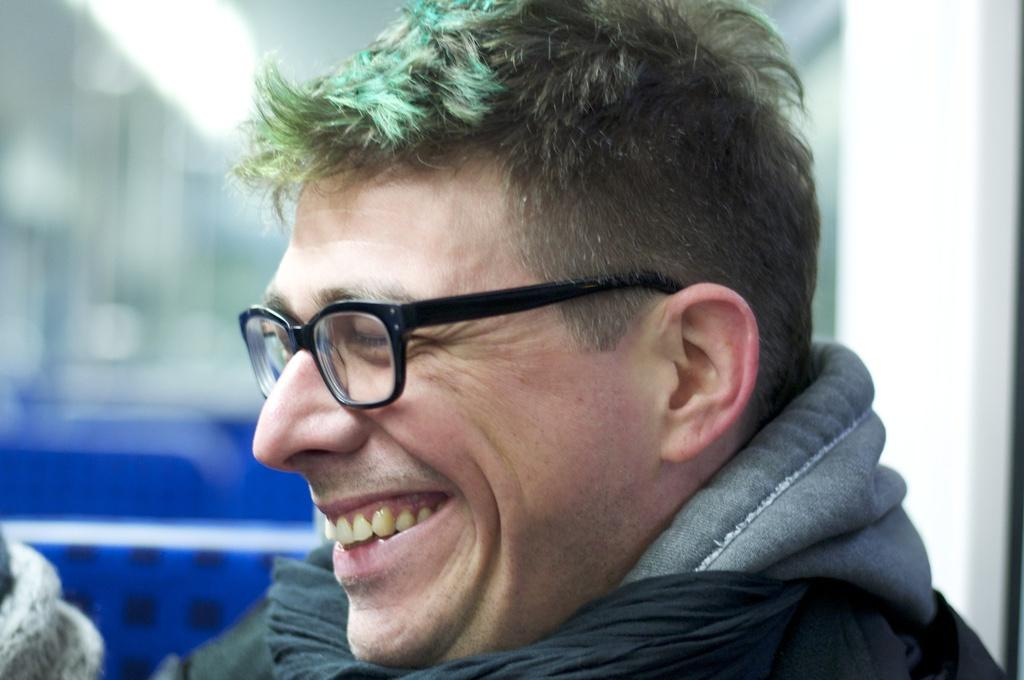Who is present in the image? There is a man in the image. What is the man doing in the image? The man is smiling in the image. What can be seen on the man's face? The man is wearing black-colored spectacles in the image. Can you describe the background of the image? The background of the image is blurry. What type of punishment is the man receiving in the image? There is no indication of punishment in the image; the man is smiling and wearing spectacles. What scene is depicted in the image? The image only shows a man smiling and wearing spectacles, so it is not possible to determine a specific scene. 